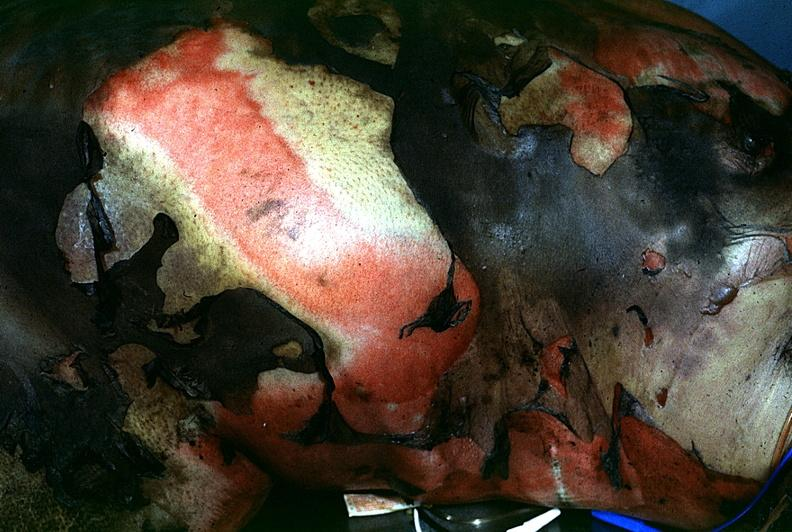do glomerulosa burn?
Answer the question using a single word or phrase. No 